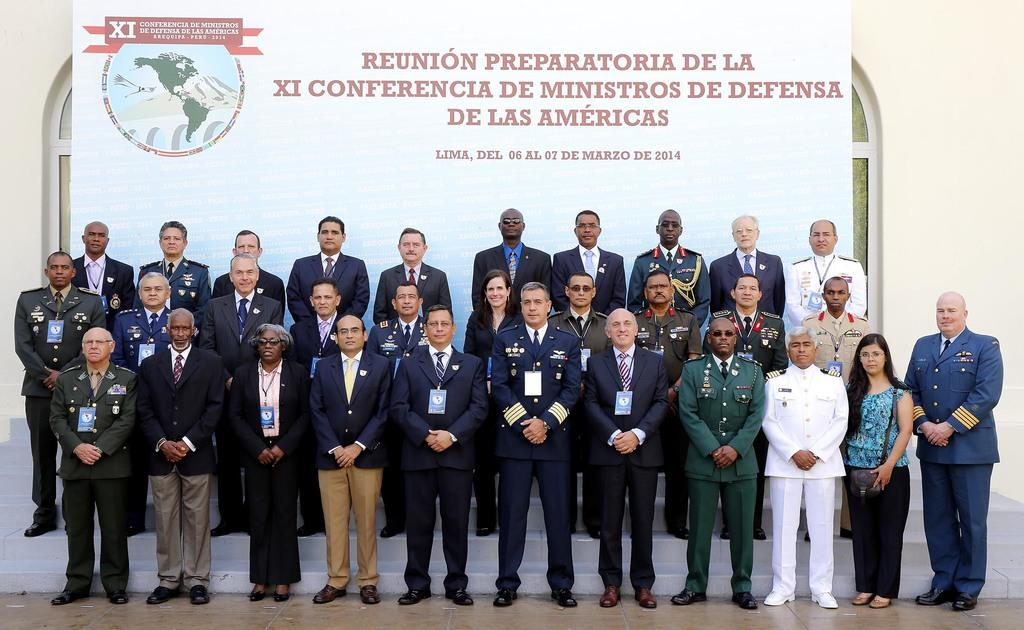What is happening in the image? There are people standing in the image. What can be seen in the background of the image? There is a board and a wall in the background of the image. What architectural feature is present at the bottom of the image? There are stairs at the bottom of the image. What surface is visible beneath the people in the image? There is a floor visible in the image. What type of cream can be seen on the quartz in the image? There is no cream or quartz present in the image. 